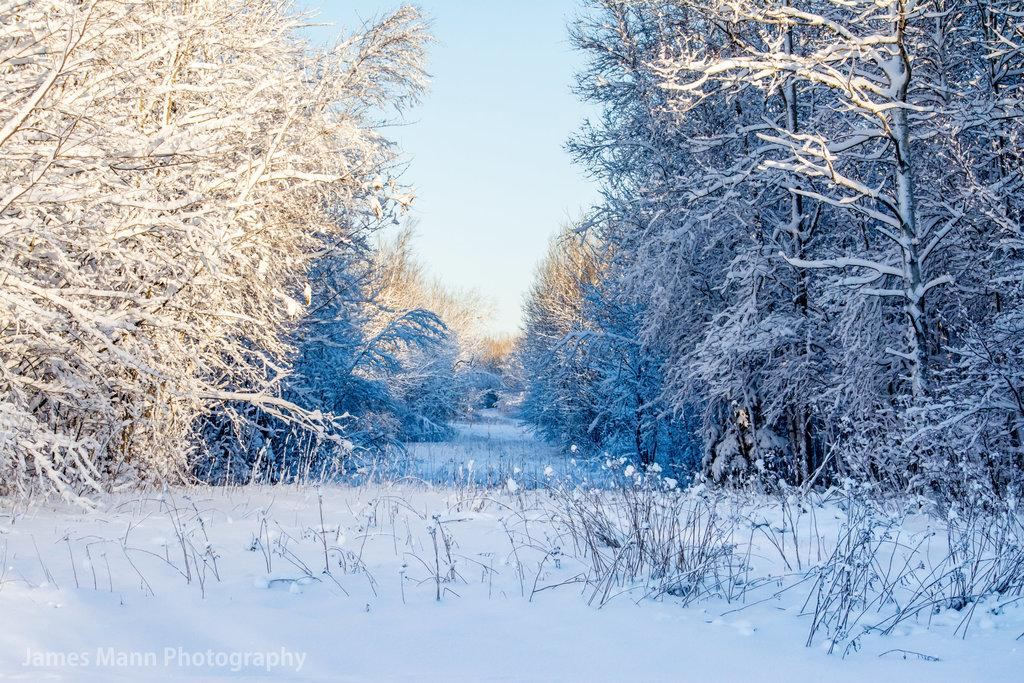What type of weather condition is depicted in the image? There is snow in the image, indicating a cold or wintry weather condition. What type of vegetation can be seen in the image? There are plants, flowers, and trees visible in the image. What is visible in the background of the image? The sky is visible in the image. What type of desk can be seen in the image? There is no desk present in the image. What emotion is the rose expressing in the image? There is no rose present in the image, so it cannot express any emotion. 